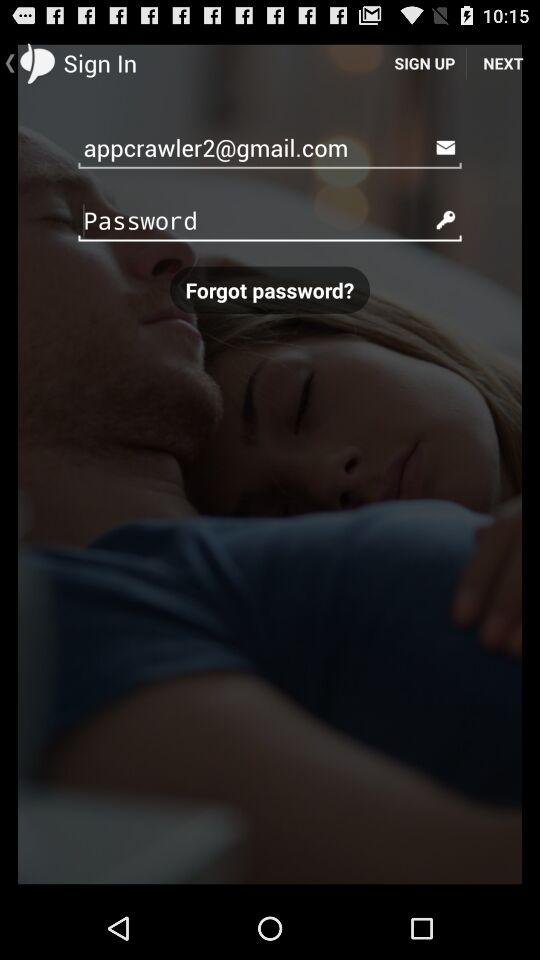What is the email address? The email address is appcrawler2@gmail.com. 